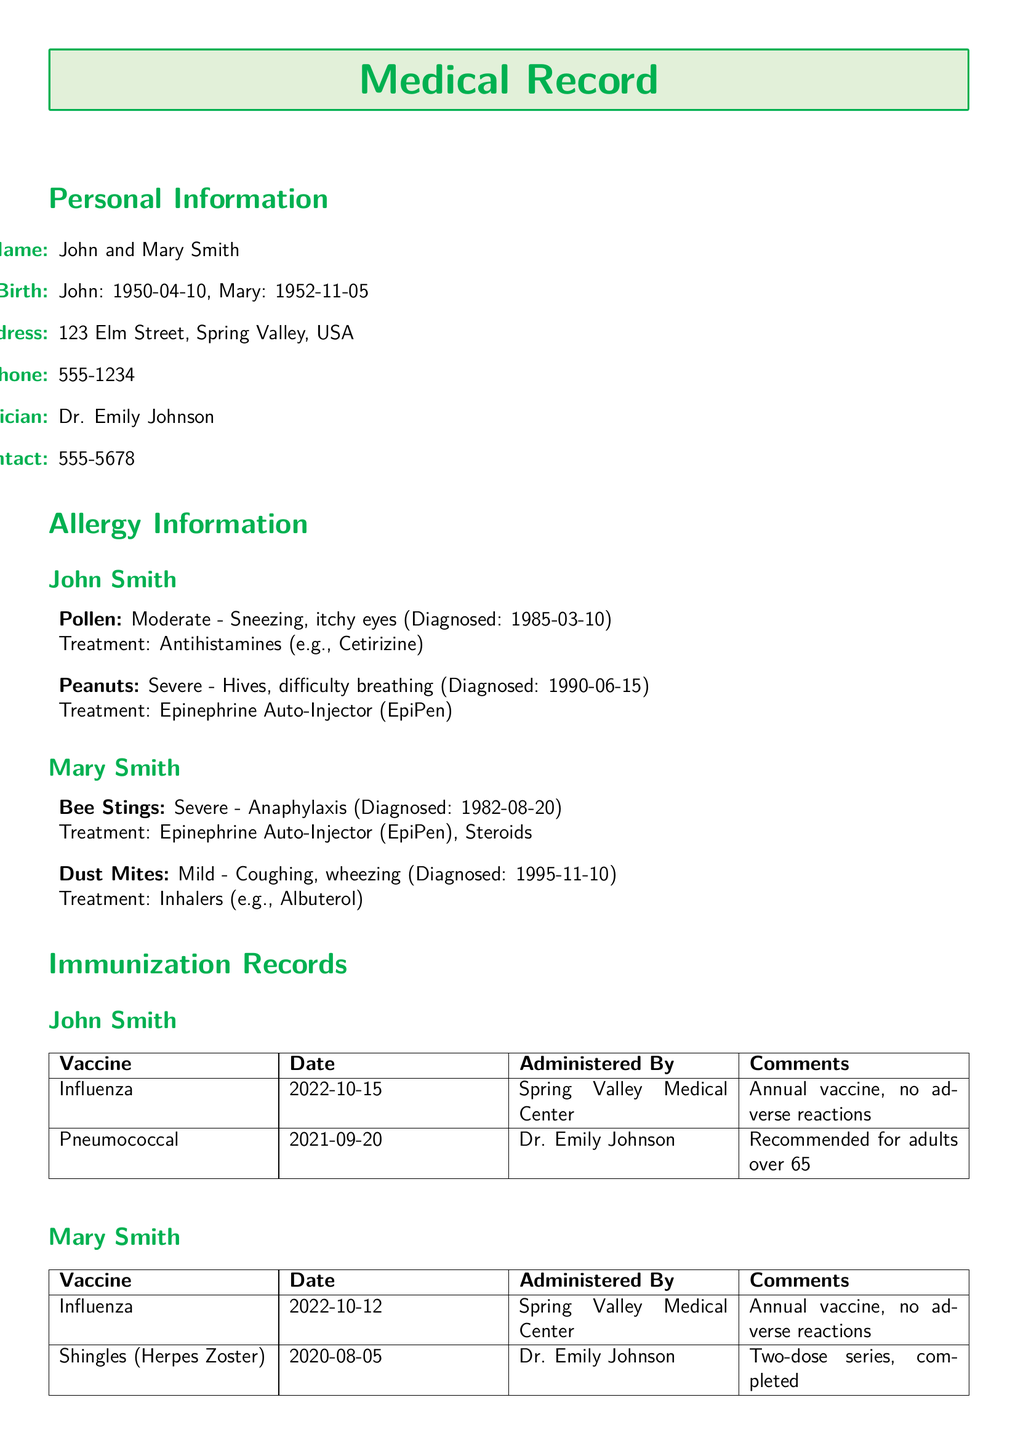What is the name of the couple? The couple's name is listed at the beginning of the document under Personal Information.
Answer: John and Mary Smith What is Mary Smith's date of birth? The date of birth for Mary is mentioned alongside her name in Personal Information.
Answer: 1952-11-05 What allergy does John Smith have that is classified as severe? The document lists John's allergies, specifying which are moderate or severe.
Answer: Peanuts When was John Smith diagnosed with a pollen allergy? The diagnosis date for John's pollen allergy is provided in the Allergy Information section.
Answer: 1985-03-10 Who administered the Influenza vaccine to Mary Smith? The person who administered the vaccine is specified in the immunization records.
Answer: Spring Valley Medical Center What is the treatment for Mary's dust mite allergy? The document states the treatment for Mary's mild allergy in the Allergy Information section.
Answer: Inhalers (e.g., Albuterol) How many doses of the Shingles vaccine did Mary Smith receive? The comments in the immunization records provide information about the dosage of the vaccine.
Answer: Two-dose series Which physician is the primary care physician for the couple? The name of the primary care physician is provided in Personal Information.
Answer: Dr. Emily Johnson 